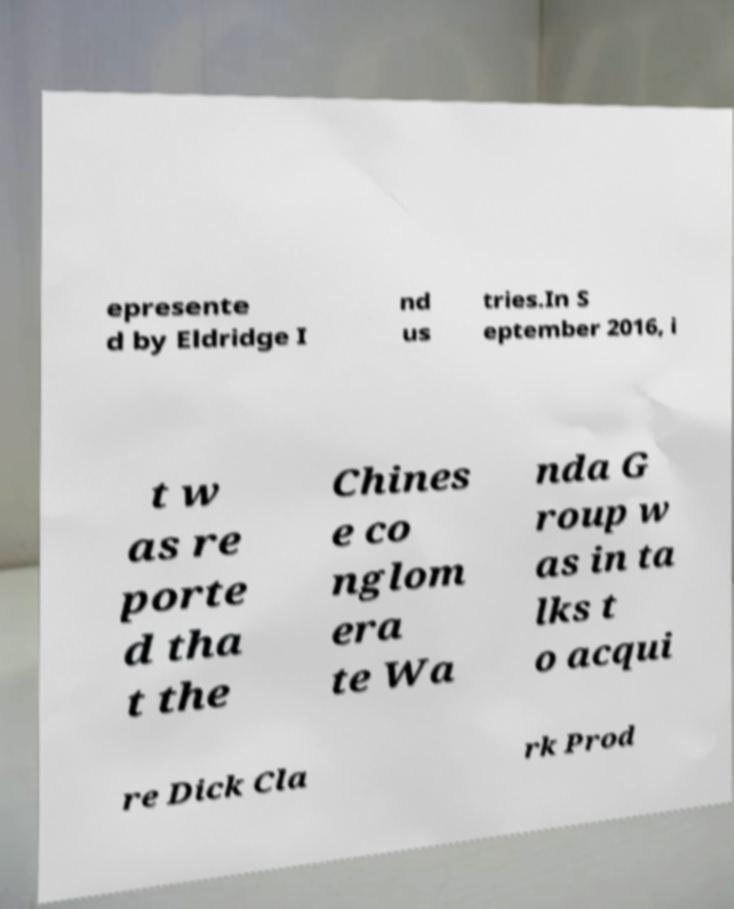Please identify and transcribe the text found in this image. epresente d by Eldridge I nd us tries.In S eptember 2016, i t w as re porte d tha t the Chines e co nglom era te Wa nda G roup w as in ta lks t o acqui re Dick Cla rk Prod 